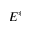<formula> <loc_0><loc_0><loc_500><loc_500>E ^ { * }</formula> 